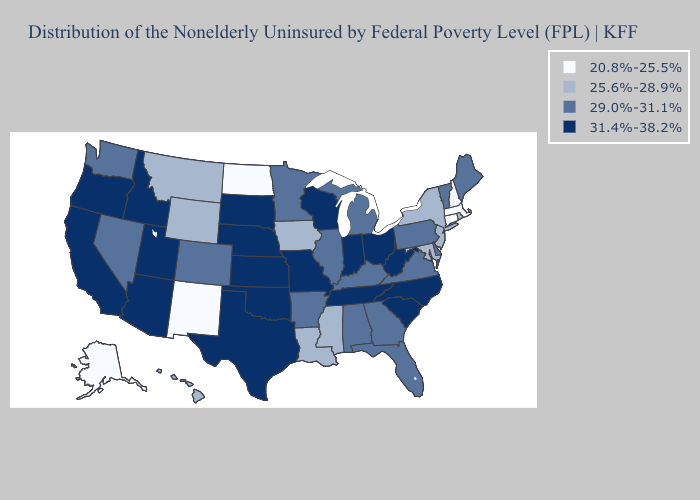What is the value of North Dakota?
Quick response, please. 20.8%-25.5%. Does Maryland have the highest value in the USA?
Be succinct. No. Name the states that have a value in the range 31.4%-38.2%?
Keep it brief. Arizona, California, Idaho, Indiana, Kansas, Missouri, Nebraska, North Carolina, Ohio, Oklahoma, Oregon, South Carolina, South Dakota, Tennessee, Texas, Utah, West Virginia, Wisconsin. What is the value of Nevada?
Write a very short answer. 29.0%-31.1%. Which states have the lowest value in the South?
Give a very brief answer. Louisiana, Maryland, Mississippi. What is the value of Alaska?
Keep it brief. 20.8%-25.5%. What is the lowest value in the USA?
Concise answer only. 20.8%-25.5%. Among the states that border Idaho , which have the lowest value?
Write a very short answer. Montana, Wyoming. What is the highest value in the South ?
Short answer required. 31.4%-38.2%. What is the value of Maryland?
Give a very brief answer. 25.6%-28.9%. What is the highest value in the MidWest ?
Write a very short answer. 31.4%-38.2%. Name the states that have a value in the range 20.8%-25.5%?
Keep it brief. Alaska, Connecticut, Massachusetts, New Hampshire, New Mexico, North Dakota. How many symbols are there in the legend?
Short answer required. 4. Among the states that border South Carolina , which have the highest value?
Short answer required. North Carolina. 